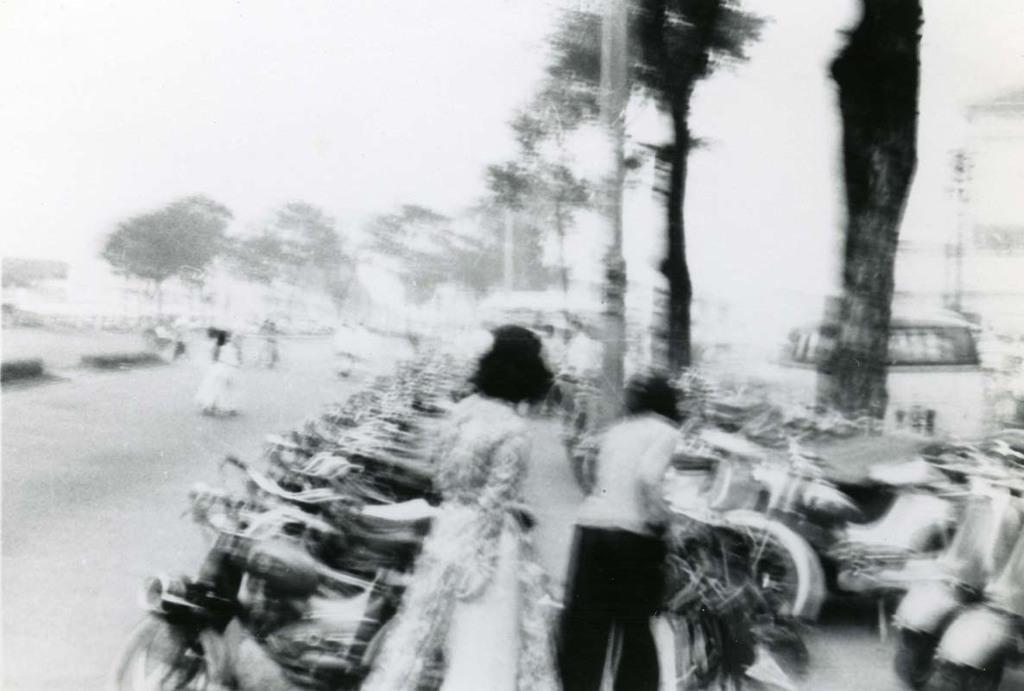How would you summarize this image in a sentence or two? This is a black and white image where we can see some people standing beside the vehicles, at the back there are some trees. Also the image is blur. 